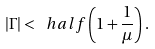<formula> <loc_0><loc_0><loc_500><loc_500>| \Gamma | < \ h a l f \left ( 1 + \frac { 1 } { \mu } \right ) .</formula> 